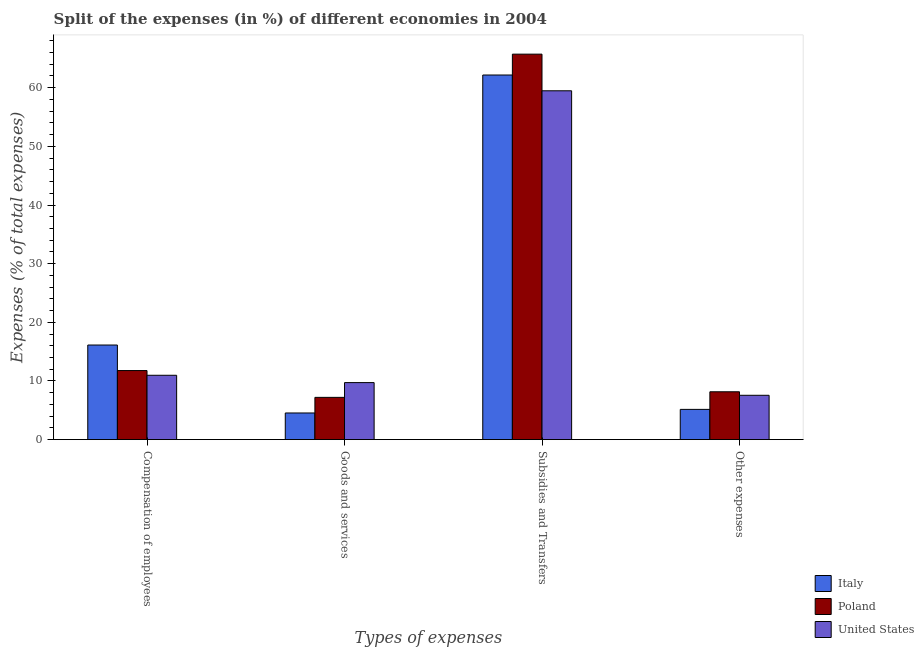Are the number of bars per tick equal to the number of legend labels?
Your response must be concise. Yes. What is the label of the 4th group of bars from the left?
Offer a terse response. Other expenses. What is the percentage of amount spent on goods and services in Poland?
Make the answer very short. 7.2. Across all countries, what is the maximum percentage of amount spent on goods and services?
Make the answer very short. 9.72. Across all countries, what is the minimum percentage of amount spent on subsidies?
Ensure brevity in your answer.  59.48. What is the total percentage of amount spent on subsidies in the graph?
Keep it short and to the point. 187.37. What is the difference between the percentage of amount spent on other expenses in Italy and that in United States?
Provide a short and direct response. -2.4. What is the difference between the percentage of amount spent on other expenses in Poland and the percentage of amount spent on goods and services in United States?
Provide a succinct answer. -1.57. What is the average percentage of amount spent on compensation of employees per country?
Provide a succinct answer. 12.96. What is the difference between the percentage of amount spent on other expenses and percentage of amount spent on compensation of employees in Italy?
Your answer should be compact. -10.97. In how many countries, is the percentage of amount spent on subsidies greater than 32 %?
Provide a short and direct response. 3. What is the ratio of the percentage of amount spent on goods and services in Italy to that in United States?
Provide a succinct answer. 0.47. Is the difference between the percentage of amount spent on other expenses in United States and Poland greater than the difference between the percentage of amount spent on subsidies in United States and Poland?
Your response must be concise. Yes. What is the difference between the highest and the second highest percentage of amount spent on other expenses?
Your response must be concise. 0.6. What is the difference between the highest and the lowest percentage of amount spent on goods and services?
Ensure brevity in your answer.  5.18. In how many countries, is the percentage of amount spent on compensation of employees greater than the average percentage of amount spent on compensation of employees taken over all countries?
Your response must be concise. 1. Is the sum of the percentage of amount spent on subsidies in United States and Italy greater than the maximum percentage of amount spent on other expenses across all countries?
Keep it short and to the point. Yes. Is it the case that in every country, the sum of the percentage of amount spent on compensation of employees and percentage of amount spent on other expenses is greater than the sum of percentage of amount spent on goods and services and percentage of amount spent on subsidies?
Offer a very short reply. No. What does the 3rd bar from the right in Goods and services represents?
Your response must be concise. Italy. Is it the case that in every country, the sum of the percentage of amount spent on compensation of employees and percentage of amount spent on goods and services is greater than the percentage of amount spent on subsidies?
Your response must be concise. No. How many bars are there?
Provide a short and direct response. 12. Are all the bars in the graph horizontal?
Keep it short and to the point. No. What is the difference between two consecutive major ticks on the Y-axis?
Keep it short and to the point. 10. Does the graph contain any zero values?
Keep it short and to the point. No. How many legend labels are there?
Make the answer very short. 3. What is the title of the graph?
Give a very brief answer. Split of the expenses (in %) of different economies in 2004. What is the label or title of the X-axis?
Offer a terse response. Types of expenses. What is the label or title of the Y-axis?
Provide a short and direct response. Expenses (% of total expenses). What is the Expenses (% of total expenses) of Italy in Compensation of employees?
Give a very brief answer. 16.13. What is the Expenses (% of total expenses) of Poland in Compensation of employees?
Ensure brevity in your answer.  11.77. What is the Expenses (% of total expenses) of United States in Compensation of employees?
Ensure brevity in your answer.  10.97. What is the Expenses (% of total expenses) in Italy in Goods and services?
Give a very brief answer. 4.54. What is the Expenses (% of total expenses) of Poland in Goods and services?
Your answer should be compact. 7.2. What is the Expenses (% of total expenses) in United States in Goods and services?
Ensure brevity in your answer.  9.72. What is the Expenses (% of total expenses) in Italy in Subsidies and Transfers?
Your answer should be compact. 62.17. What is the Expenses (% of total expenses) of Poland in Subsidies and Transfers?
Provide a short and direct response. 65.72. What is the Expenses (% of total expenses) of United States in Subsidies and Transfers?
Make the answer very short. 59.48. What is the Expenses (% of total expenses) in Italy in Other expenses?
Your answer should be compact. 5.15. What is the Expenses (% of total expenses) in Poland in Other expenses?
Provide a succinct answer. 8.16. What is the Expenses (% of total expenses) of United States in Other expenses?
Provide a succinct answer. 7.56. Across all Types of expenses, what is the maximum Expenses (% of total expenses) of Italy?
Your answer should be compact. 62.17. Across all Types of expenses, what is the maximum Expenses (% of total expenses) in Poland?
Provide a short and direct response. 65.72. Across all Types of expenses, what is the maximum Expenses (% of total expenses) of United States?
Offer a terse response. 59.48. Across all Types of expenses, what is the minimum Expenses (% of total expenses) in Italy?
Your response must be concise. 4.54. Across all Types of expenses, what is the minimum Expenses (% of total expenses) in Poland?
Provide a short and direct response. 7.2. Across all Types of expenses, what is the minimum Expenses (% of total expenses) in United States?
Ensure brevity in your answer.  7.56. What is the total Expenses (% of total expenses) in Italy in the graph?
Make the answer very short. 87.99. What is the total Expenses (% of total expenses) in Poland in the graph?
Your answer should be very brief. 92.86. What is the total Expenses (% of total expenses) of United States in the graph?
Offer a very short reply. 87.72. What is the difference between the Expenses (% of total expenses) in Italy in Compensation of employees and that in Goods and services?
Give a very brief answer. 11.59. What is the difference between the Expenses (% of total expenses) of Poland in Compensation of employees and that in Goods and services?
Your answer should be compact. 4.57. What is the difference between the Expenses (% of total expenses) of United States in Compensation of employees and that in Goods and services?
Your response must be concise. 1.25. What is the difference between the Expenses (% of total expenses) in Italy in Compensation of employees and that in Subsidies and Transfers?
Offer a terse response. -46.04. What is the difference between the Expenses (% of total expenses) in Poland in Compensation of employees and that in Subsidies and Transfers?
Your response must be concise. -53.95. What is the difference between the Expenses (% of total expenses) in United States in Compensation of employees and that in Subsidies and Transfers?
Your response must be concise. -48.51. What is the difference between the Expenses (% of total expenses) in Italy in Compensation of employees and that in Other expenses?
Make the answer very short. 10.97. What is the difference between the Expenses (% of total expenses) in Poland in Compensation of employees and that in Other expenses?
Provide a short and direct response. 3.62. What is the difference between the Expenses (% of total expenses) of United States in Compensation of employees and that in Other expenses?
Your response must be concise. 3.41. What is the difference between the Expenses (% of total expenses) of Italy in Goods and services and that in Subsidies and Transfers?
Make the answer very short. -57.63. What is the difference between the Expenses (% of total expenses) of Poland in Goods and services and that in Subsidies and Transfers?
Provide a succinct answer. -58.52. What is the difference between the Expenses (% of total expenses) in United States in Goods and services and that in Subsidies and Transfers?
Provide a succinct answer. -49.76. What is the difference between the Expenses (% of total expenses) in Italy in Goods and services and that in Other expenses?
Your answer should be compact. -0.61. What is the difference between the Expenses (% of total expenses) of Poland in Goods and services and that in Other expenses?
Provide a succinct answer. -0.95. What is the difference between the Expenses (% of total expenses) of United States in Goods and services and that in Other expenses?
Provide a succinct answer. 2.16. What is the difference between the Expenses (% of total expenses) of Italy in Subsidies and Transfers and that in Other expenses?
Offer a very short reply. 57.01. What is the difference between the Expenses (% of total expenses) in Poland in Subsidies and Transfers and that in Other expenses?
Your answer should be compact. 57.57. What is the difference between the Expenses (% of total expenses) in United States in Subsidies and Transfers and that in Other expenses?
Give a very brief answer. 51.92. What is the difference between the Expenses (% of total expenses) in Italy in Compensation of employees and the Expenses (% of total expenses) in Poland in Goods and services?
Give a very brief answer. 8.93. What is the difference between the Expenses (% of total expenses) of Italy in Compensation of employees and the Expenses (% of total expenses) of United States in Goods and services?
Ensure brevity in your answer.  6.41. What is the difference between the Expenses (% of total expenses) in Poland in Compensation of employees and the Expenses (% of total expenses) in United States in Goods and services?
Make the answer very short. 2.05. What is the difference between the Expenses (% of total expenses) of Italy in Compensation of employees and the Expenses (% of total expenses) of Poland in Subsidies and Transfers?
Make the answer very short. -49.6. What is the difference between the Expenses (% of total expenses) in Italy in Compensation of employees and the Expenses (% of total expenses) in United States in Subsidies and Transfers?
Your answer should be very brief. -43.35. What is the difference between the Expenses (% of total expenses) of Poland in Compensation of employees and the Expenses (% of total expenses) of United States in Subsidies and Transfers?
Give a very brief answer. -47.7. What is the difference between the Expenses (% of total expenses) of Italy in Compensation of employees and the Expenses (% of total expenses) of Poland in Other expenses?
Make the answer very short. 7.97. What is the difference between the Expenses (% of total expenses) in Italy in Compensation of employees and the Expenses (% of total expenses) in United States in Other expenses?
Your response must be concise. 8.57. What is the difference between the Expenses (% of total expenses) of Poland in Compensation of employees and the Expenses (% of total expenses) of United States in Other expenses?
Offer a terse response. 4.22. What is the difference between the Expenses (% of total expenses) of Italy in Goods and services and the Expenses (% of total expenses) of Poland in Subsidies and Transfers?
Your answer should be compact. -61.18. What is the difference between the Expenses (% of total expenses) in Italy in Goods and services and the Expenses (% of total expenses) in United States in Subsidies and Transfers?
Offer a very short reply. -54.94. What is the difference between the Expenses (% of total expenses) of Poland in Goods and services and the Expenses (% of total expenses) of United States in Subsidies and Transfers?
Make the answer very short. -52.28. What is the difference between the Expenses (% of total expenses) in Italy in Goods and services and the Expenses (% of total expenses) in Poland in Other expenses?
Ensure brevity in your answer.  -3.61. What is the difference between the Expenses (% of total expenses) in Italy in Goods and services and the Expenses (% of total expenses) in United States in Other expenses?
Provide a short and direct response. -3.02. What is the difference between the Expenses (% of total expenses) in Poland in Goods and services and the Expenses (% of total expenses) in United States in Other expenses?
Give a very brief answer. -0.36. What is the difference between the Expenses (% of total expenses) in Italy in Subsidies and Transfers and the Expenses (% of total expenses) in Poland in Other expenses?
Your response must be concise. 54.01. What is the difference between the Expenses (% of total expenses) in Italy in Subsidies and Transfers and the Expenses (% of total expenses) in United States in Other expenses?
Offer a terse response. 54.61. What is the difference between the Expenses (% of total expenses) of Poland in Subsidies and Transfers and the Expenses (% of total expenses) of United States in Other expenses?
Make the answer very short. 58.17. What is the average Expenses (% of total expenses) in Italy per Types of expenses?
Your response must be concise. 22. What is the average Expenses (% of total expenses) in Poland per Types of expenses?
Your answer should be very brief. 23.21. What is the average Expenses (% of total expenses) in United States per Types of expenses?
Keep it short and to the point. 21.93. What is the difference between the Expenses (% of total expenses) in Italy and Expenses (% of total expenses) in Poland in Compensation of employees?
Provide a succinct answer. 4.35. What is the difference between the Expenses (% of total expenses) in Italy and Expenses (% of total expenses) in United States in Compensation of employees?
Keep it short and to the point. 5.16. What is the difference between the Expenses (% of total expenses) of Poland and Expenses (% of total expenses) of United States in Compensation of employees?
Your answer should be very brief. 0.81. What is the difference between the Expenses (% of total expenses) of Italy and Expenses (% of total expenses) of Poland in Goods and services?
Provide a short and direct response. -2.66. What is the difference between the Expenses (% of total expenses) of Italy and Expenses (% of total expenses) of United States in Goods and services?
Offer a very short reply. -5.18. What is the difference between the Expenses (% of total expenses) of Poland and Expenses (% of total expenses) of United States in Goods and services?
Your answer should be compact. -2.52. What is the difference between the Expenses (% of total expenses) in Italy and Expenses (% of total expenses) in Poland in Subsidies and Transfers?
Provide a short and direct response. -3.56. What is the difference between the Expenses (% of total expenses) in Italy and Expenses (% of total expenses) in United States in Subsidies and Transfers?
Give a very brief answer. 2.69. What is the difference between the Expenses (% of total expenses) in Poland and Expenses (% of total expenses) in United States in Subsidies and Transfers?
Make the answer very short. 6.25. What is the difference between the Expenses (% of total expenses) of Italy and Expenses (% of total expenses) of Poland in Other expenses?
Give a very brief answer. -3. What is the difference between the Expenses (% of total expenses) of Italy and Expenses (% of total expenses) of United States in Other expenses?
Your answer should be compact. -2.4. What is the difference between the Expenses (% of total expenses) of Poland and Expenses (% of total expenses) of United States in Other expenses?
Your answer should be compact. 0.6. What is the ratio of the Expenses (% of total expenses) in Italy in Compensation of employees to that in Goods and services?
Your answer should be very brief. 3.55. What is the ratio of the Expenses (% of total expenses) of Poland in Compensation of employees to that in Goods and services?
Offer a terse response. 1.63. What is the ratio of the Expenses (% of total expenses) in United States in Compensation of employees to that in Goods and services?
Offer a terse response. 1.13. What is the ratio of the Expenses (% of total expenses) of Italy in Compensation of employees to that in Subsidies and Transfers?
Your answer should be compact. 0.26. What is the ratio of the Expenses (% of total expenses) in Poland in Compensation of employees to that in Subsidies and Transfers?
Offer a terse response. 0.18. What is the ratio of the Expenses (% of total expenses) in United States in Compensation of employees to that in Subsidies and Transfers?
Your answer should be very brief. 0.18. What is the ratio of the Expenses (% of total expenses) in Italy in Compensation of employees to that in Other expenses?
Keep it short and to the point. 3.13. What is the ratio of the Expenses (% of total expenses) of Poland in Compensation of employees to that in Other expenses?
Your answer should be very brief. 1.44. What is the ratio of the Expenses (% of total expenses) of United States in Compensation of employees to that in Other expenses?
Your answer should be compact. 1.45. What is the ratio of the Expenses (% of total expenses) of Italy in Goods and services to that in Subsidies and Transfers?
Give a very brief answer. 0.07. What is the ratio of the Expenses (% of total expenses) of Poland in Goods and services to that in Subsidies and Transfers?
Ensure brevity in your answer.  0.11. What is the ratio of the Expenses (% of total expenses) of United States in Goods and services to that in Subsidies and Transfers?
Provide a succinct answer. 0.16. What is the ratio of the Expenses (% of total expenses) of Italy in Goods and services to that in Other expenses?
Provide a short and direct response. 0.88. What is the ratio of the Expenses (% of total expenses) in Poland in Goods and services to that in Other expenses?
Provide a short and direct response. 0.88. What is the ratio of the Expenses (% of total expenses) in United States in Goods and services to that in Other expenses?
Give a very brief answer. 1.29. What is the ratio of the Expenses (% of total expenses) in Italy in Subsidies and Transfers to that in Other expenses?
Your answer should be compact. 12.06. What is the ratio of the Expenses (% of total expenses) in Poland in Subsidies and Transfers to that in Other expenses?
Keep it short and to the point. 8.06. What is the ratio of the Expenses (% of total expenses) of United States in Subsidies and Transfers to that in Other expenses?
Keep it short and to the point. 7.87. What is the difference between the highest and the second highest Expenses (% of total expenses) in Italy?
Your answer should be very brief. 46.04. What is the difference between the highest and the second highest Expenses (% of total expenses) of Poland?
Make the answer very short. 53.95. What is the difference between the highest and the second highest Expenses (% of total expenses) in United States?
Make the answer very short. 48.51. What is the difference between the highest and the lowest Expenses (% of total expenses) of Italy?
Your answer should be compact. 57.63. What is the difference between the highest and the lowest Expenses (% of total expenses) of Poland?
Provide a short and direct response. 58.52. What is the difference between the highest and the lowest Expenses (% of total expenses) of United States?
Offer a terse response. 51.92. 